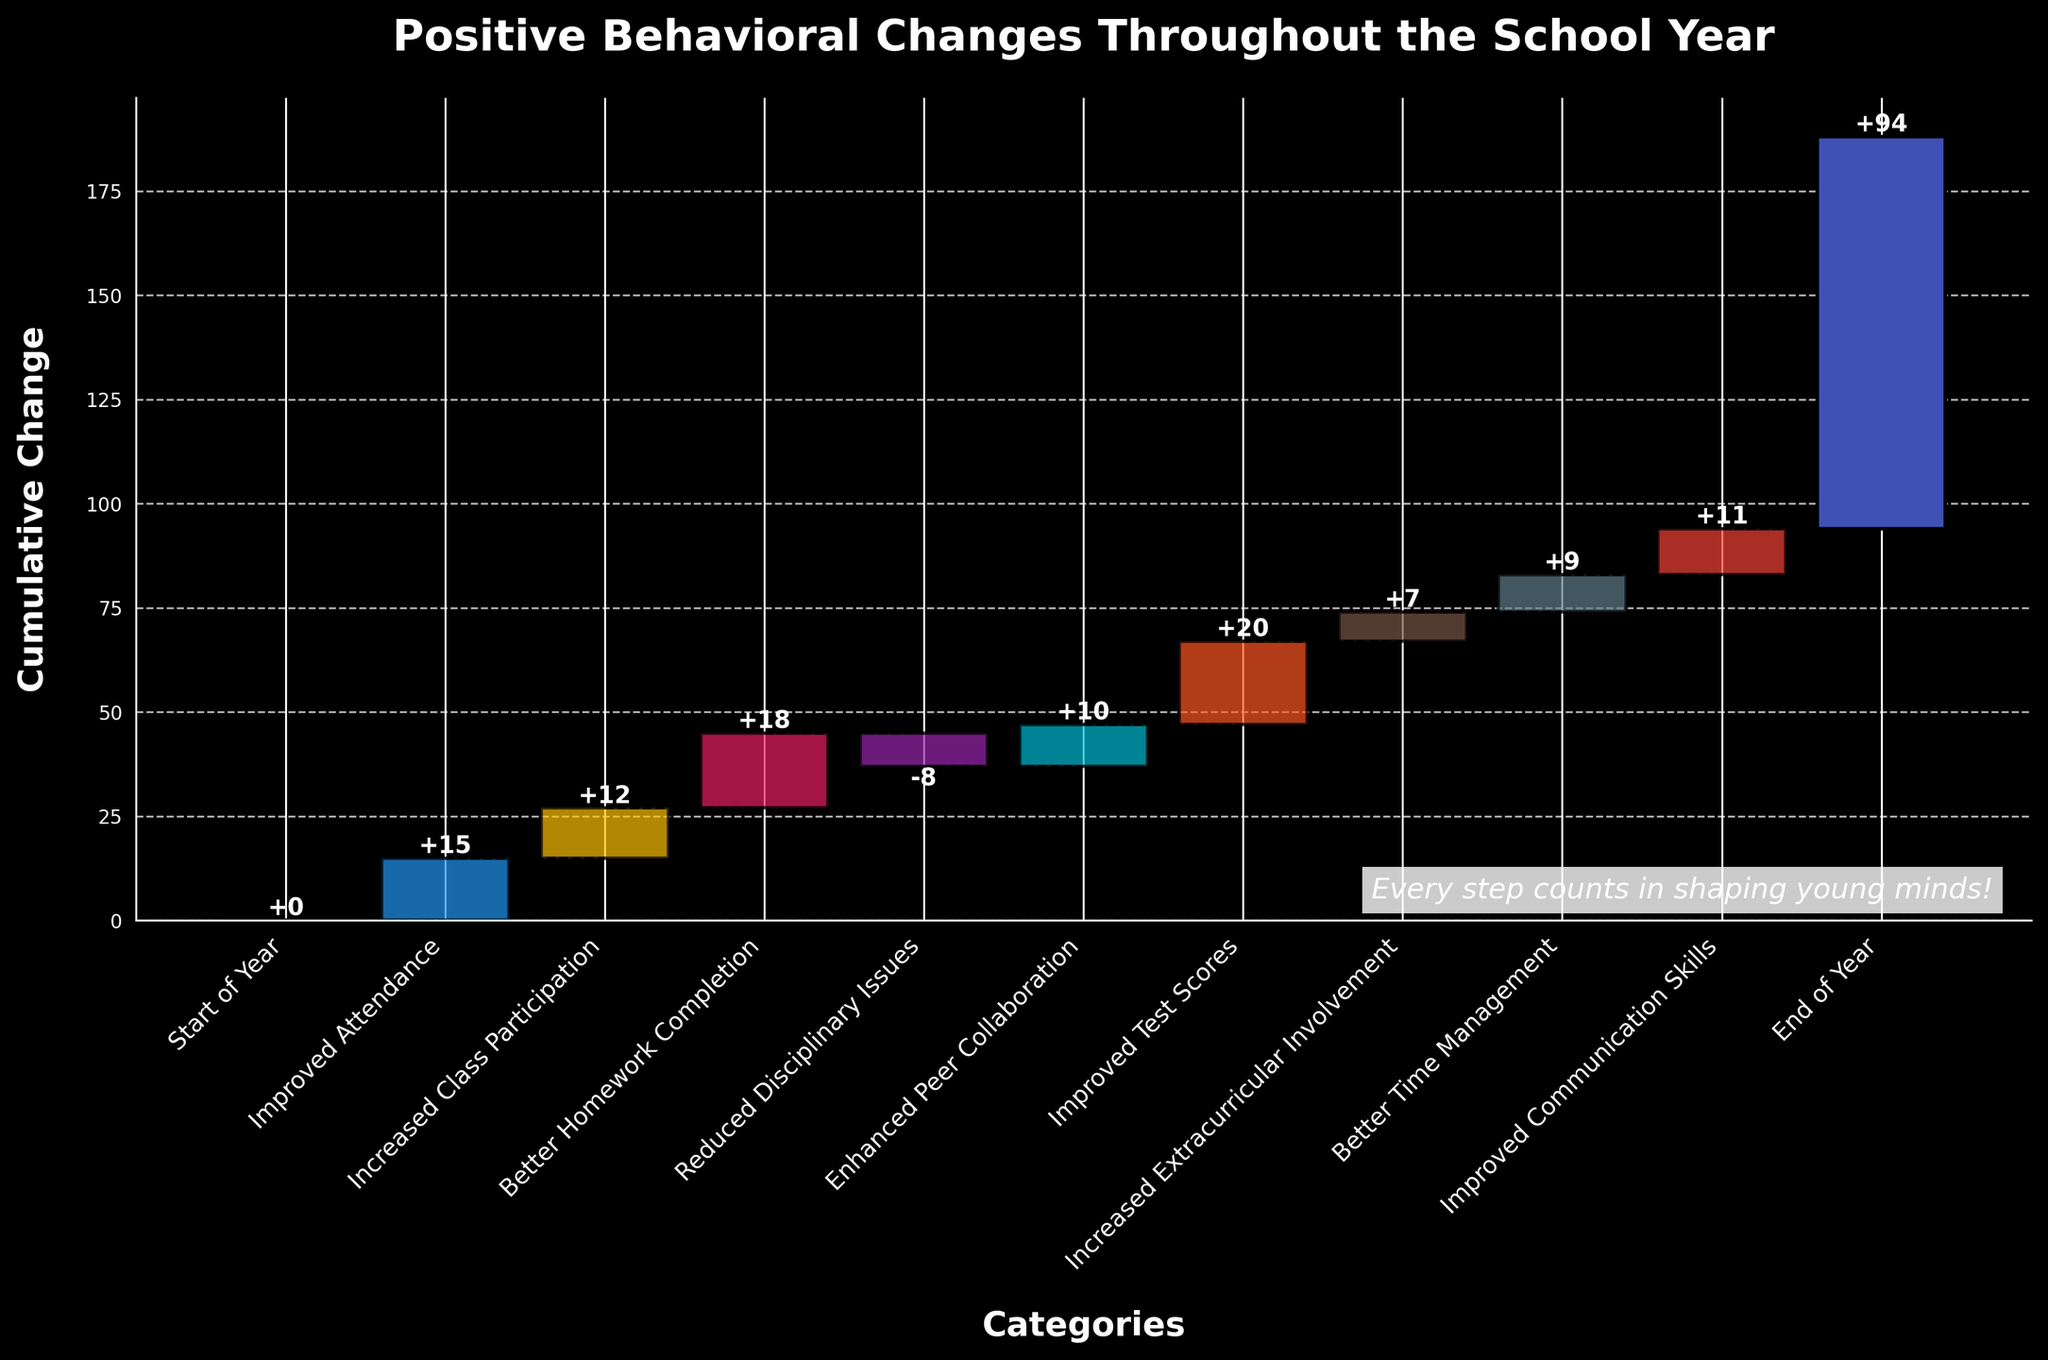What's the title of the chart? The title is located at the top of the chart and reads: "Positive Behavioral Changes Throughout the School Year."
Answer: Positive Behavioral Changes Throughout the School Year How many behavior categories are included in the chart? Counting the bars on the x-axis, there are 11 categories, including the "Start of Year" and "End of Year."
Answer: 11 Which category contributed the most positively to the cumulative change? The height of the bar for "Improved Test Scores" is tallest above the baseline, which indicates it has the highest positive contribution of 20.
Answer: Improved Test Scores What is the cumulative change in behavior at the end of the year? The cumulative value at the "End of Year" bar marks the aggregated change from the beginning to the end of the year shown at the top of the chart, which is 94.
Answer: 94 Which category had a negative impact on the cumulative change? The category "Reduced Disciplinary Issues" shows a bar below the baseline representing a negative value of -8.
Answer: Reduced Disciplinary Issues What is the total positive change in behavior by adding up all the improvements? Adding all the individual positive changes: 15 (Improved Attendance) + 12 (Increased Class Participation) + 18 (Better Homework Completion) + 10 (Enhanced Peer Collaboration) + 20 (Improved Test Scores) + 7 (Increased Extracurricular Involvement) + 9 (Better Time Management) + 11 (Improved Communication Skills) equals 102.
Answer: 102 Compare the changes due to "Increased Class Participation" and "Better Homework Completion." Which one has a higher impact? "Better Homework Completion" has a higher impact at 18 compared to "Increased Class Participation" which is 12.
Answer: Better Homework Completion What are the two categories with the lowest positive changes in behavior? The categories with the smallest positive bars, indicating the lowest changes, are "Increased Extracurricular Involvement" with 7 and "Increased Class Participation" with 12.
Answer: Increased Extracurricular Involvement and Increased Class Participation By how much did the "Increased Extracurricular Involvement" improve the cumulative change? The bar for "Increased Extracurricular Involvement" shows a value of 7, adding this value to the cumulative change.
Answer: 7 